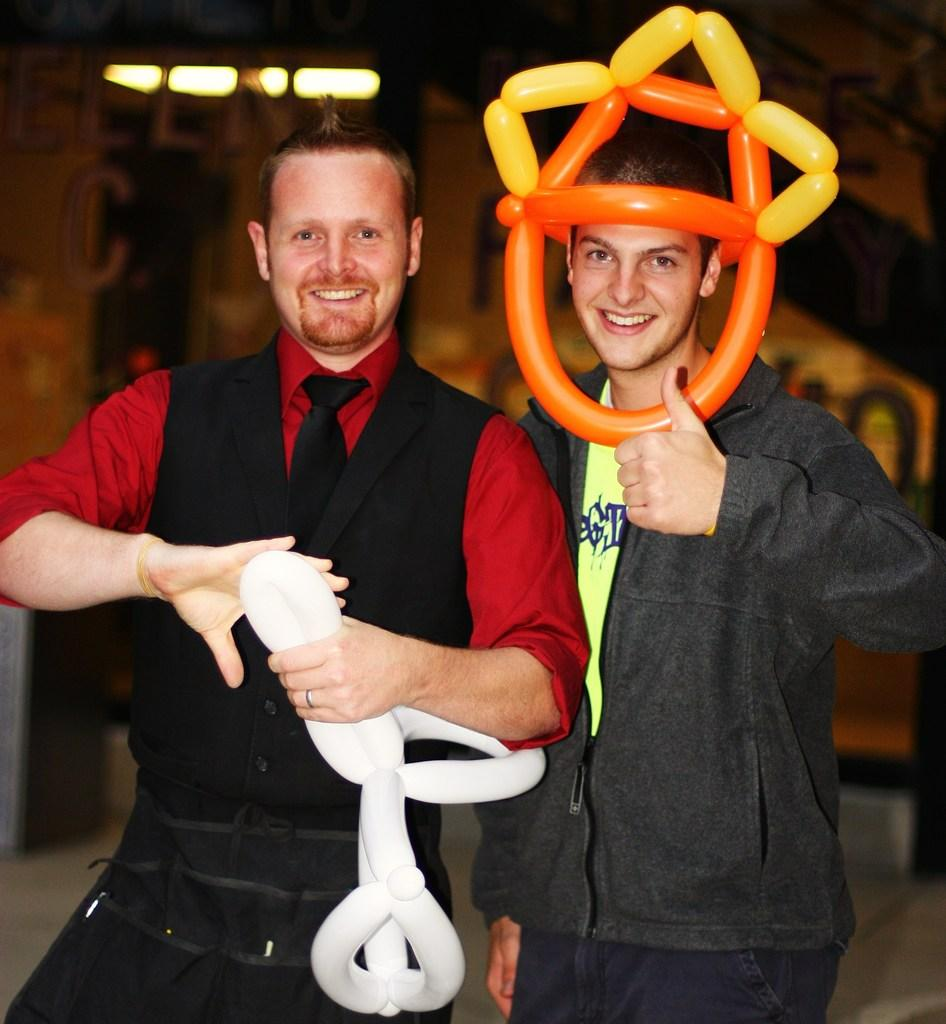How many people are in the image? There are two persons in the image. What are the two persons doing? The two persons are standing and holding air balloons. What can be seen in the background of the image? There is a wall, lights, and other objects in the background of the image. What type of silver rod can be seen in the image? There is no silver rod present in the image. How many icicles are hanging from the wall in the image? There are no icicles present in the image; it is an indoor setting with a wall and lights in the background. 